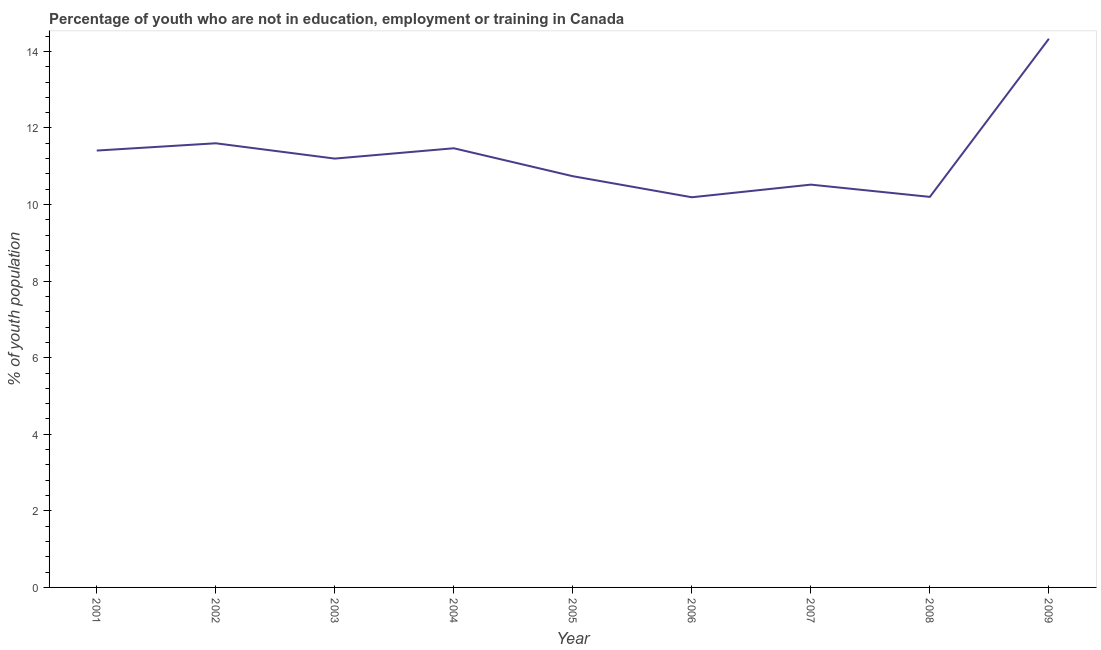What is the unemployed youth population in 2003?
Give a very brief answer. 11.2. Across all years, what is the maximum unemployed youth population?
Your answer should be very brief. 14.33. Across all years, what is the minimum unemployed youth population?
Your answer should be very brief. 10.19. What is the sum of the unemployed youth population?
Provide a short and direct response. 101.66. What is the difference between the unemployed youth population in 2002 and 2009?
Your response must be concise. -2.73. What is the average unemployed youth population per year?
Your answer should be very brief. 11.3. What is the median unemployed youth population?
Your response must be concise. 11.2. In how many years, is the unemployed youth population greater than 7.6 %?
Your answer should be compact. 9. What is the ratio of the unemployed youth population in 2004 to that in 2005?
Offer a terse response. 1.07. Is the unemployed youth population in 2002 less than that in 2007?
Provide a short and direct response. No. Is the difference between the unemployed youth population in 2001 and 2003 greater than the difference between any two years?
Provide a succinct answer. No. What is the difference between the highest and the second highest unemployed youth population?
Offer a terse response. 2.73. What is the difference between the highest and the lowest unemployed youth population?
Your answer should be compact. 4.14. How many years are there in the graph?
Your answer should be compact. 9. Are the values on the major ticks of Y-axis written in scientific E-notation?
Offer a terse response. No. What is the title of the graph?
Ensure brevity in your answer.  Percentage of youth who are not in education, employment or training in Canada. What is the label or title of the Y-axis?
Offer a very short reply. % of youth population. What is the % of youth population in 2001?
Your response must be concise. 11.41. What is the % of youth population of 2002?
Provide a short and direct response. 11.6. What is the % of youth population of 2003?
Keep it short and to the point. 11.2. What is the % of youth population of 2004?
Ensure brevity in your answer.  11.47. What is the % of youth population in 2005?
Ensure brevity in your answer.  10.74. What is the % of youth population of 2006?
Offer a terse response. 10.19. What is the % of youth population of 2007?
Give a very brief answer. 10.52. What is the % of youth population of 2008?
Give a very brief answer. 10.2. What is the % of youth population of 2009?
Offer a very short reply. 14.33. What is the difference between the % of youth population in 2001 and 2002?
Ensure brevity in your answer.  -0.19. What is the difference between the % of youth population in 2001 and 2003?
Make the answer very short. 0.21. What is the difference between the % of youth population in 2001 and 2004?
Offer a terse response. -0.06. What is the difference between the % of youth population in 2001 and 2005?
Keep it short and to the point. 0.67. What is the difference between the % of youth population in 2001 and 2006?
Keep it short and to the point. 1.22. What is the difference between the % of youth population in 2001 and 2007?
Offer a terse response. 0.89. What is the difference between the % of youth population in 2001 and 2008?
Your answer should be very brief. 1.21. What is the difference between the % of youth population in 2001 and 2009?
Your answer should be compact. -2.92. What is the difference between the % of youth population in 2002 and 2004?
Offer a terse response. 0.13. What is the difference between the % of youth population in 2002 and 2005?
Offer a very short reply. 0.86. What is the difference between the % of youth population in 2002 and 2006?
Your response must be concise. 1.41. What is the difference between the % of youth population in 2002 and 2007?
Your response must be concise. 1.08. What is the difference between the % of youth population in 2002 and 2009?
Your response must be concise. -2.73. What is the difference between the % of youth population in 2003 and 2004?
Offer a very short reply. -0.27. What is the difference between the % of youth population in 2003 and 2005?
Keep it short and to the point. 0.46. What is the difference between the % of youth population in 2003 and 2006?
Offer a terse response. 1.01. What is the difference between the % of youth population in 2003 and 2007?
Your answer should be compact. 0.68. What is the difference between the % of youth population in 2003 and 2009?
Offer a terse response. -3.13. What is the difference between the % of youth population in 2004 and 2005?
Give a very brief answer. 0.73. What is the difference between the % of youth population in 2004 and 2006?
Your answer should be compact. 1.28. What is the difference between the % of youth population in 2004 and 2008?
Ensure brevity in your answer.  1.27. What is the difference between the % of youth population in 2004 and 2009?
Offer a terse response. -2.86. What is the difference between the % of youth population in 2005 and 2006?
Your answer should be compact. 0.55. What is the difference between the % of youth population in 2005 and 2007?
Provide a succinct answer. 0.22. What is the difference between the % of youth population in 2005 and 2008?
Ensure brevity in your answer.  0.54. What is the difference between the % of youth population in 2005 and 2009?
Your answer should be compact. -3.59. What is the difference between the % of youth population in 2006 and 2007?
Provide a succinct answer. -0.33. What is the difference between the % of youth population in 2006 and 2008?
Make the answer very short. -0.01. What is the difference between the % of youth population in 2006 and 2009?
Give a very brief answer. -4.14. What is the difference between the % of youth population in 2007 and 2008?
Provide a succinct answer. 0.32. What is the difference between the % of youth population in 2007 and 2009?
Offer a very short reply. -3.81. What is the difference between the % of youth population in 2008 and 2009?
Your response must be concise. -4.13. What is the ratio of the % of youth population in 2001 to that in 2002?
Your response must be concise. 0.98. What is the ratio of the % of youth population in 2001 to that in 2005?
Ensure brevity in your answer.  1.06. What is the ratio of the % of youth population in 2001 to that in 2006?
Give a very brief answer. 1.12. What is the ratio of the % of youth population in 2001 to that in 2007?
Your answer should be compact. 1.08. What is the ratio of the % of youth population in 2001 to that in 2008?
Your answer should be very brief. 1.12. What is the ratio of the % of youth population in 2001 to that in 2009?
Offer a very short reply. 0.8. What is the ratio of the % of youth population in 2002 to that in 2003?
Give a very brief answer. 1.04. What is the ratio of the % of youth population in 2002 to that in 2006?
Ensure brevity in your answer.  1.14. What is the ratio of the % of youth population in 2002 to that in 2007?
Provide a succinct answer. 1.1. What is the ratio of the % of youth population in 2002 to that in 2008?
Provide a succinct answer. 1.14. What is the ratio of the % of youth population in 2002 to that in 2009?
Make the answer very short. 0.81. What is the ratio of the % of youth population in 2003 to that in 2004?
Make the answer very short. 0.98. What is the ratio of the % of youth population in 2003 to that in 2005?
Your answer should be very brief. 1.04. What is the ratio of the % of youth population in 2003 to that in 2006?
Your answer should be very brief. 1.1. What is the ratio of the % of youth population in 2003 to that in 2007?
Give a very brief answer. 1.06. What is the ratio of the % of youth population in 2003 to that in 2008?
Make the answer very short. 1.1. What is the ratio of the % of youth population in 2003 to that in 2009?
Provide a short and direct response. 0.78. What is the ratio of the % of youth population in 2004 to that in 2005?
Give a very brief answer. 1.07. What is the ratio of the % of youth population in 2004 to that in 2006?
Give a very brief answer. 1.13. What is the ratio of the % of youth population in 2004 to that in 2007?
Make the answer very short. 1.09. What is the ratio of the % of youth population in 2005 to that in 2006?
Make the answer very short. 1.05. What is the ratio of the % of youth population in 2005 to that in 2007?
Provide a succinct answer. 1.02. What is the ratio of the % of youth population in 2005 to that in 2008?
Give a very brief answer. 1.05. What is the ratio of the % of youth population in 2005 to that in 2009?
Your answer should be very brief. 0.75. What is the ratio of the % of youth population in 2006 to that in 2007?
Keep it short and to the point. 0.97. What is the ratio of the % of youth population in 2006 to that in 2009?
Offer a very short reply. 0.71. What is the ratio of the % of youth population in 2007 to that in 2008?
Your answer should be compact. 1.03. What is the ratio of the % of youth population in 2007 to that in 2009?
Offer a terse response. 0.73. What is the ratio of the % of youth population in 2008 to that in 2009?
Your answer should be very brief. 0.71. 